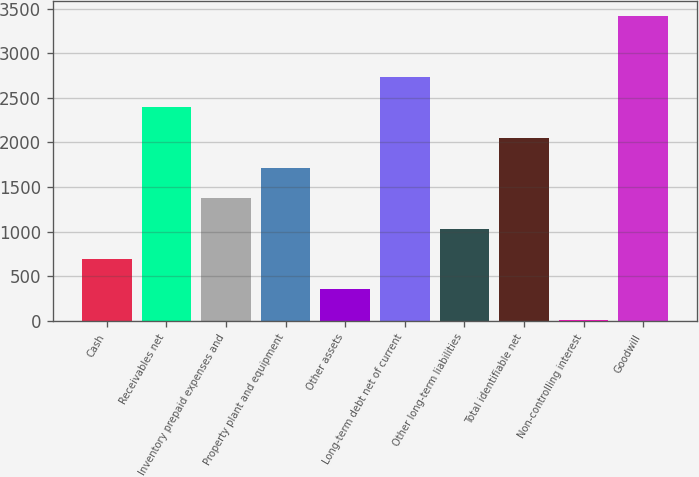<chart> <loc_0><loc_0><loc_500><loc_500><bar_chart><fcel>Cash<fcel>Receivables net<fcel>Inventory prepaid expenses and<fcel>Property plant and equipment<fcel>Other assets<fcel>Long-term debt net of current<fcel>Other long-term liabilities<fcel>Total identifiable net<fcel>Non-controlling interest<fcel>Goodwill<nl><fcel>691<fcel>2393.5<fcel>1372<fcel>1712.5<fcel>350.5<fcel>2734<fcel>1031.5<fcel>2053<fcel>10<fcel>3415<nl></chart> 